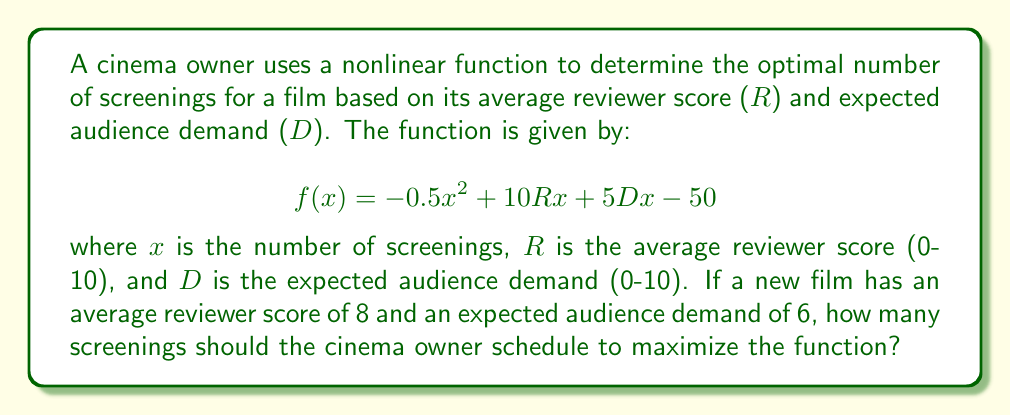Can you answer this question? To find the optimal number of screenings, we need to maximize the given function. We can do this by finding the value of x where the derivative of f(x) equals zero.

Step 1: Calculate the derivative of f(x)
$$f'(x) = -x + 10R + 5D$$

Step 2: Set the derivative equal to zero and solve for x
$$-x + 10R + 5D = 0$$
$$x = 10R + 5D$$

Step 3: Substitute the given values for R and D
R = 8
D = 6
$$x = 10(8) + 5(6)$$
$$x = 80 + 30 = 110$$

Step 4: Verify that this is a maximum by checking the second derivative
$$f''(x) = -1$$
Since f''(x) is negative, the critical point is indeed a maximum.

Therefore, the optimal number of screenings is 110.
Answer: 110 screenings 